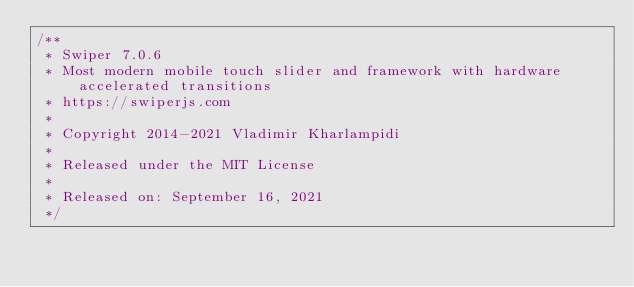<code> <loc_0><loc_0><loc_500><loc_500><_CSS_>/**
 * Swiper 7.0.6
 * Most modern mobile touch slider and framework with hardware accelerated transitions
 * https://swiperjs.com
 *
 * Copyright 2014-2021 Vladimir Kharlampidi
 *
 * Released under the MIT License
 *
 * Released on: September 16, 2021
 */
</code> 